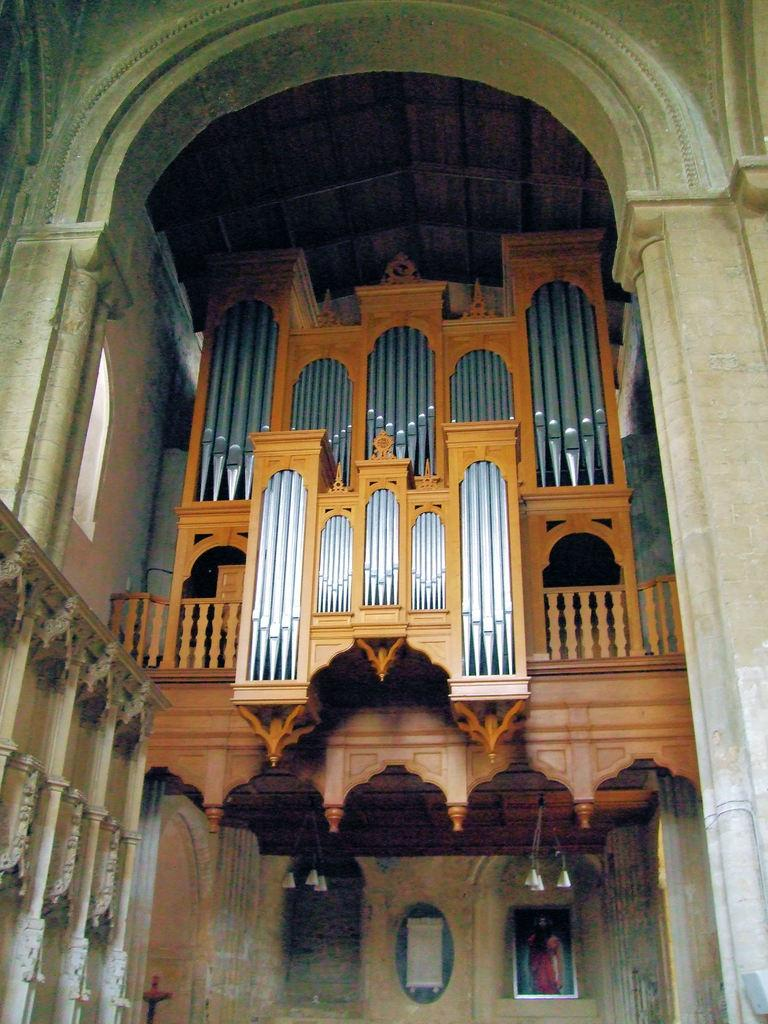What type of space is shown in the image? The image is an inside view of a room. What architectural feature can be seen in the room? There is an arch in the room. What allows natural light to enter the room? There is a window in the room. What might provide safety or support in the room? There is a railing in the room. What covers the top of the room? There is a roof in the room. What surrounds the room to create a sense of enclosure? There are walls in the room. What type of decorative items are present in the room? There are photo frames in the room. What provides illumination in the room? There are lights in the room. What type of spade is being used to care for the plants in the room? There are no plants or spades present in the image; it is an inside view of a room with various architectural and decorative elements. 